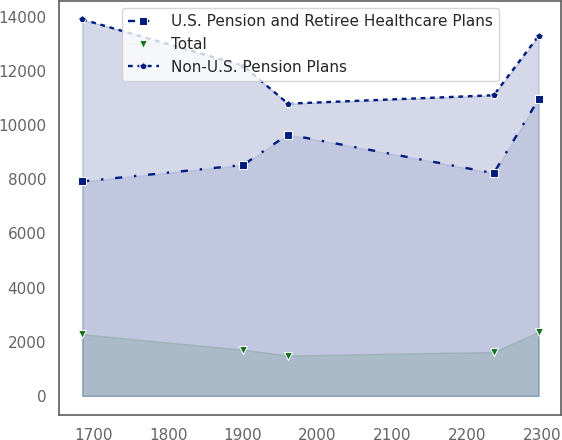Convert chart to OTSL. <chart><loc_0><loc_0><loc_500><loc_500><line_chart><ecel><fcel>U.S. Pension and Retiree Healthcare Plans<fcel>Total<fcel>Non-U.S. Pension Plans<nl><fcel>1685.04<fcel>7915.81<fcel>2272.89<fcel>13898.4<nl><fcel>1900.31<fcel>8522.91<fcel>1703.58<fcel>12186<nl><fcel>1960.43<fcel>9647.93<fcel>1487.29<fcel>10787.3<nl><fcel>2235.62<fcel>8219.36<fcel>1616.96<fcel>11098.4<nl><fcel>2295.74<fcel>10951.3<fcel>2359.51<fcel>13287.8<nl></chart> 